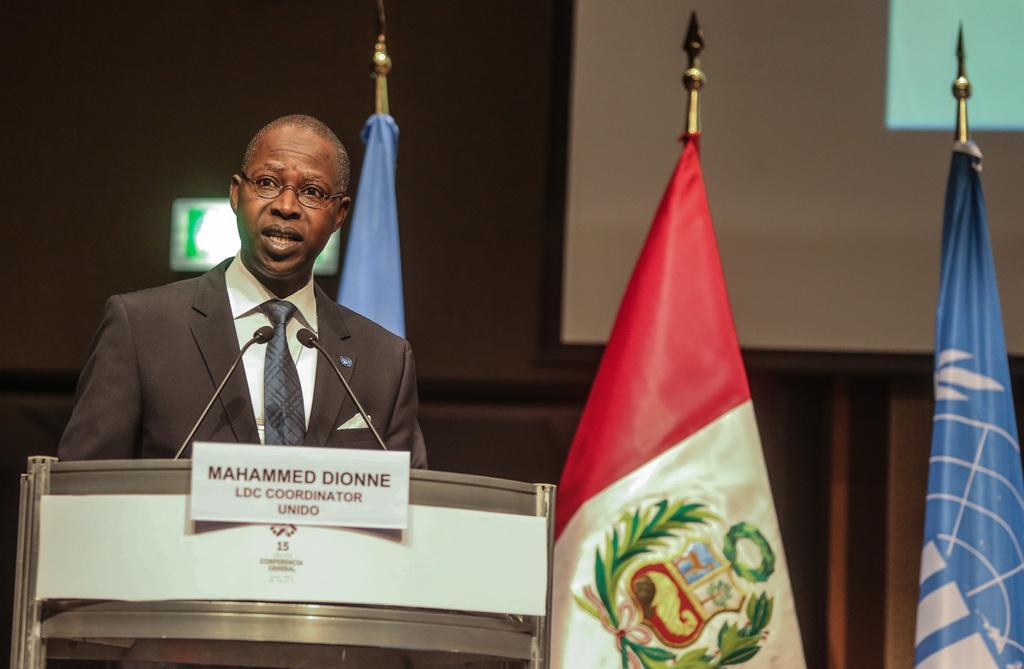Could you give a brief overview of what you see in this image? In this image I see a man who is wearing a suit and he is standing in front of a podium and I see the paper over here on which there is something written and I see the flags in the background and I see the projector screen over here and I can also see mics over here. 